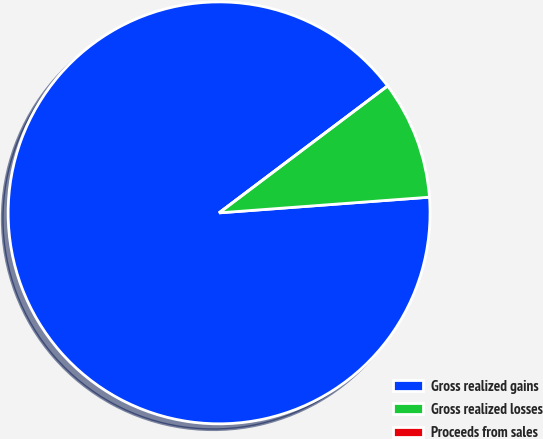<chart> <loc_0><loc_0><loc_500><loc_500><pie_chart><fcel>Gross realized gains<fcel>Gross realized losses<fcel>Proceeds from sales<nl><fcel>90.9%<fcel>9.09%<fcel>0.0%<nl></chart> 